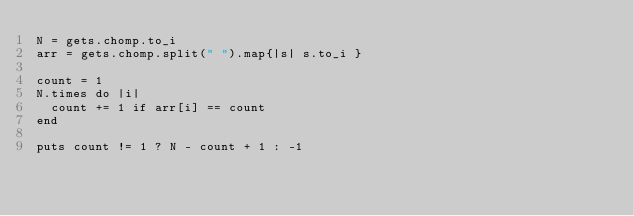<code> <loc_0><loc_0><loc_500><loc_500><_Ruby_>N = gets.chomp.to_i
arr = gets.chomp.split(" ").map{|s| s.to_i }

count = 1
N.times do |i|
  count += 1 if arr[i] == count
end

puts count != 1 ? N - count + 1 : -1
</code> 